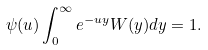<formula> <loc_0><loc_0><loc_500><loc_500>\psi ( u ) \int _ { 0 } ^ { \infty } e ^ { - u y } W ( y ) d y = 1 .</formula> 